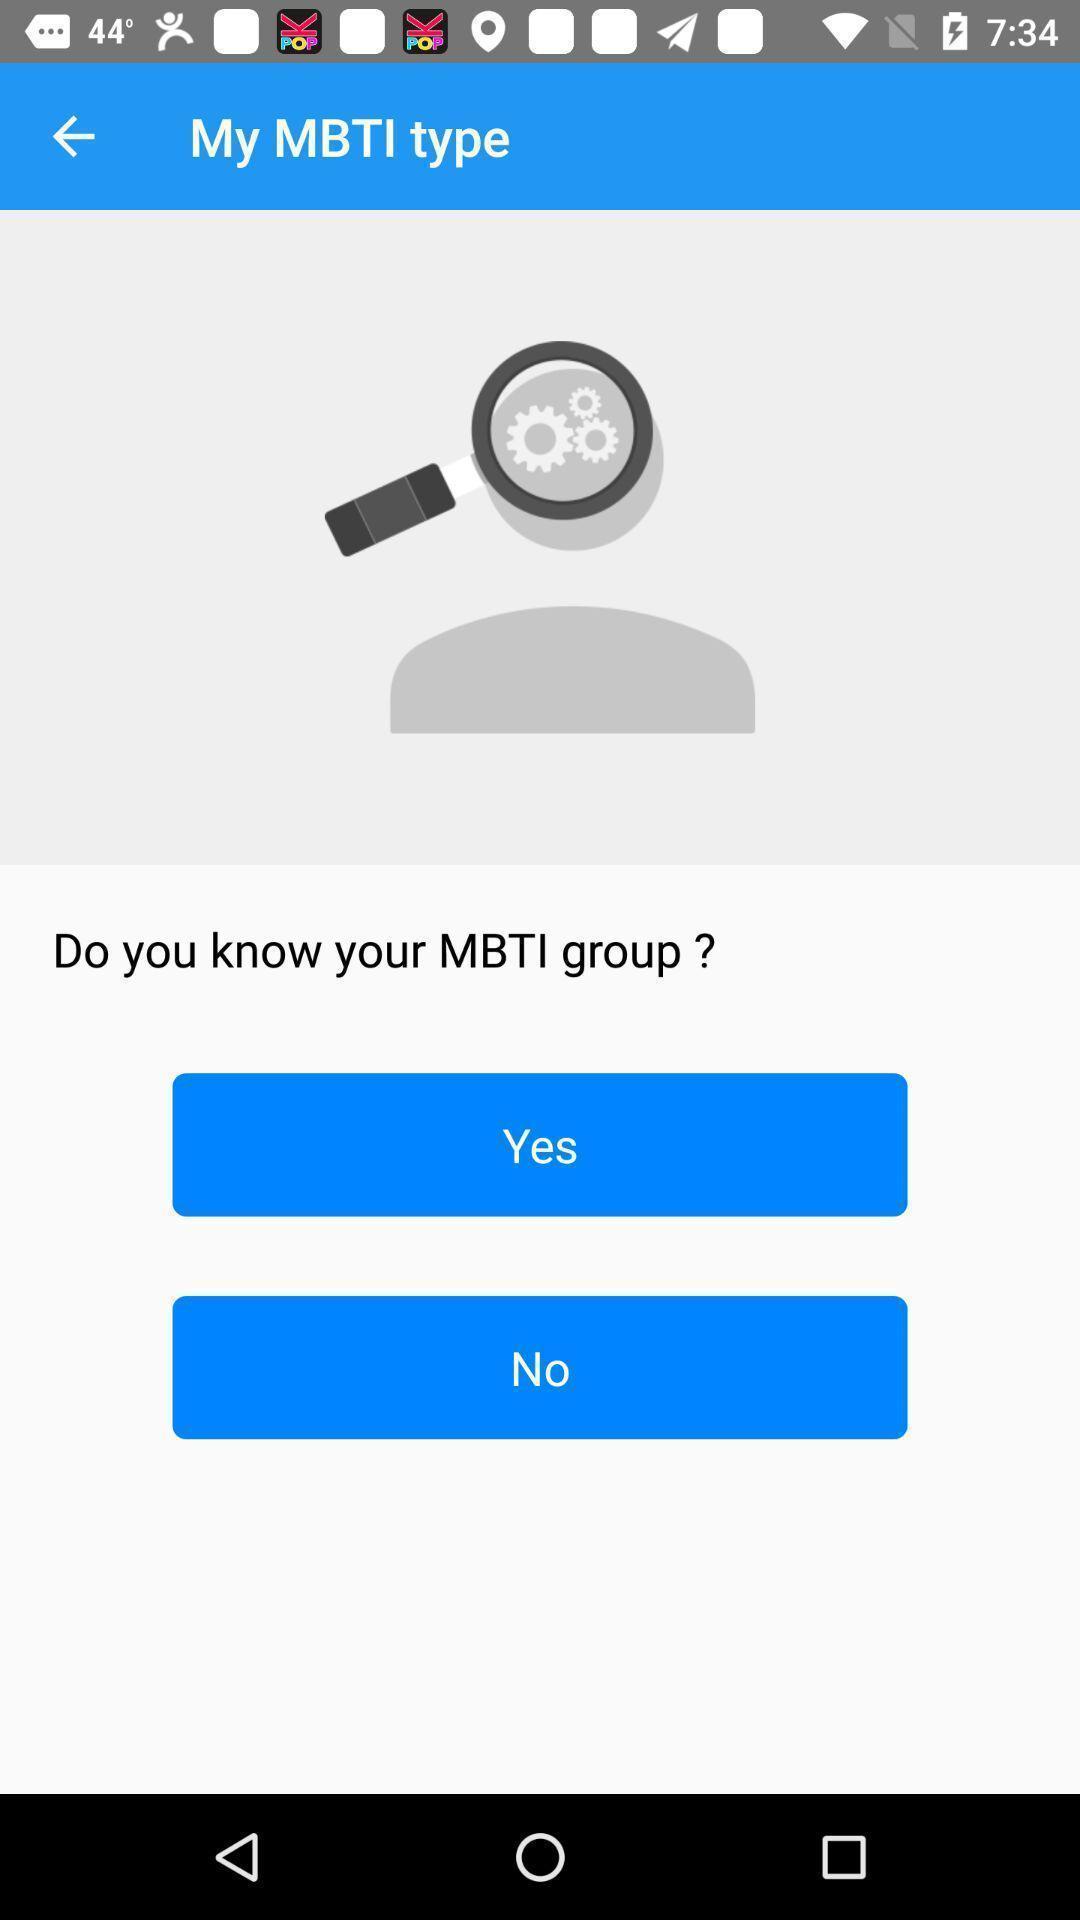Provide a description of this screenshot. Screen shows multiple options. 